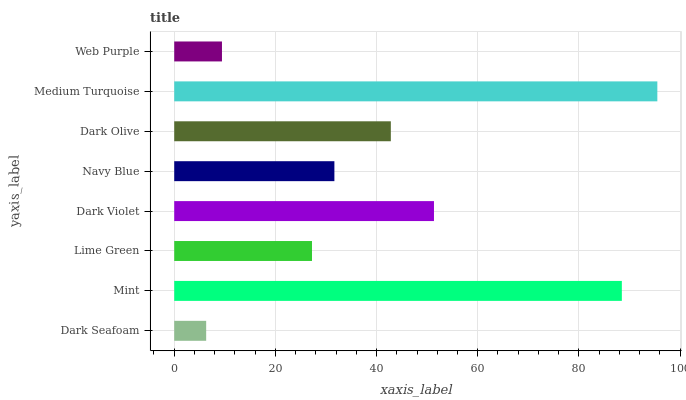Is Dark Seafoam the minimum?
Answer yes or no. Yes. Is Medium Turquoise the maximum?
Answer yes or no. Yes. Is Mint the minimum?
Answer yes or no. No. Is Mint the maximum?
Answer yes or no. No. Is Mint greater than Dark Seafoam?
Answer yes or no. Yes. Is Dark Seafoam less than Mint?
Answer yes or no. Yes. Is Dark Seafoam greater than Mint?
Answer yes or no. No. Is Mint less than Dark Seafoam?
Answer yes or no. No. Is Dark Olive the high median?
Answer yes or no. Yes. Is Navy Blue the low median?
Answer yes or no. Yes. Is Dark Seafoam the high median?
Answer yes or no. No. Is Dark Seafoam the low median?
Answer yes or no. No. 